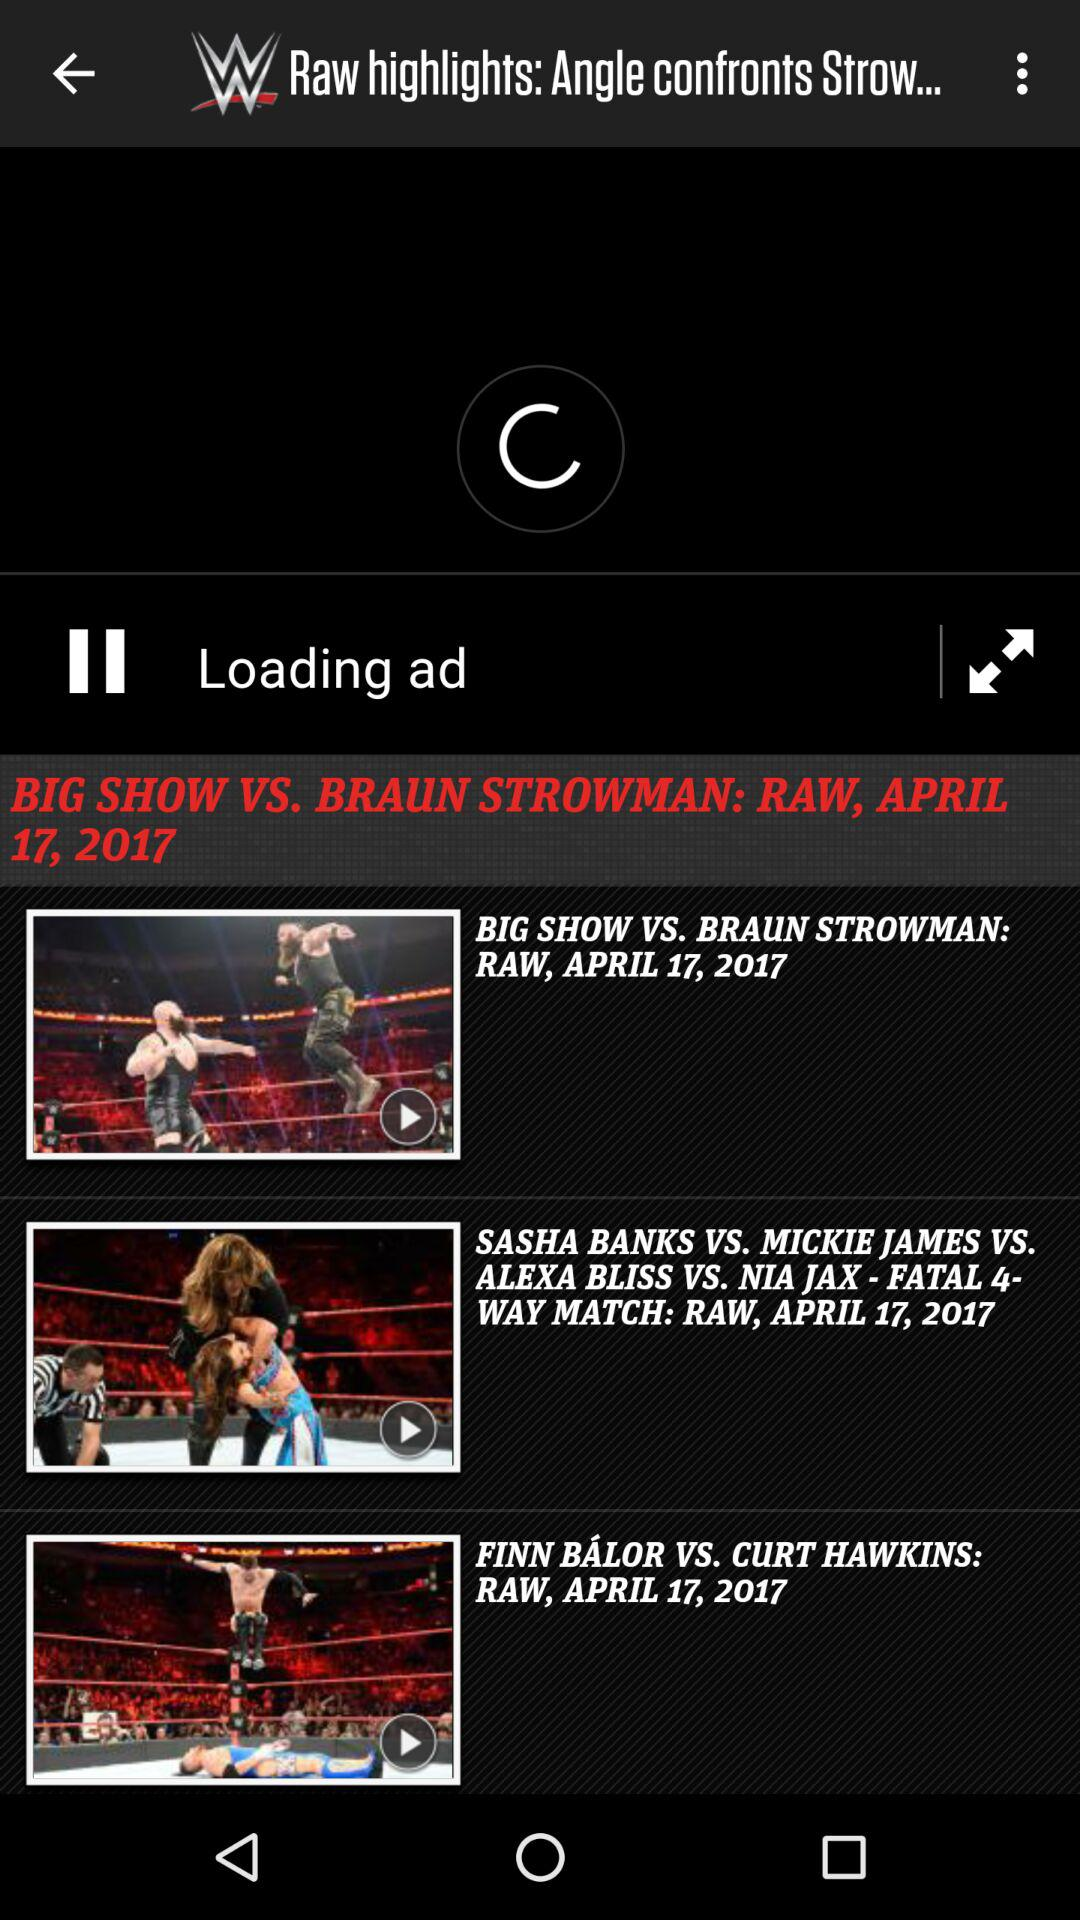How many wrestling matches are there in total?
Answer the question using a single word or phrase. 3 